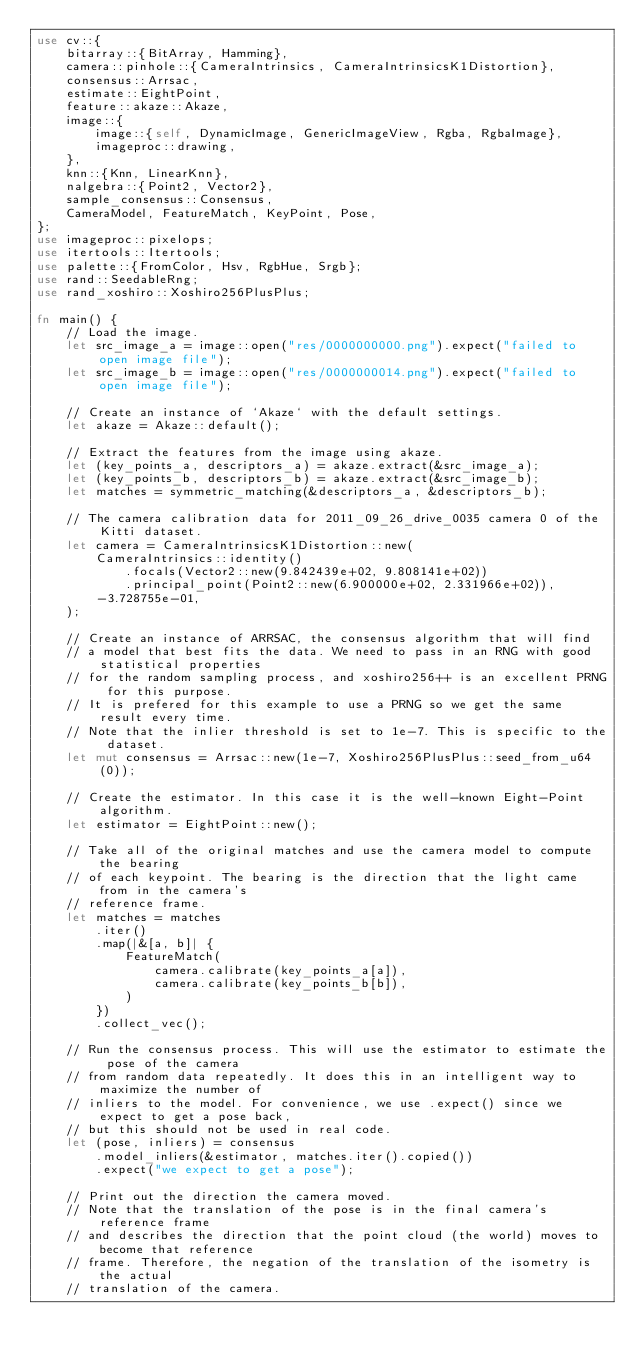<code> <loc_0><loc_0><loc_500><loc_500><_Rust_>use cv::{
    bitarray::{BitArray, Hamming},
    camera::pinhole::{CameraIntrinsics, CameraIntrinsicsK1Distortion},
    consensus::Arrsac,
    estimate::EightPoint,
    feature::akaze::Akaze,
    image::{
        image::{self, DynamicImage, GenericImageView, Rgba, RgbaImage},
        imageproc::drawing,
    },
    knn::{Knn, LinearKnn},
    nalgebra::{Point2, Vector2},
    sample_consensus::Consensus,
    CameraModel, FeatureMatch, KeyPoint, Pose,
};
use imageproc::pixelops;
use itertools::Itertools;
use palette::{FromColor, Hsv, RgbHue, Srgb};
use rand::SeedableRng;
use rand_xoshiro::Xoshiro256PlusPlus;

fn main() {
    // Load the image.
    let src_image_a = image::open("res/0000000000.png").expect("failed to open image file");
    let src_image_b = image::open("res/0000000014.png").expect("failed to open image file");

    // Create an instance of `Akaze` with the default settings.
    let akaze = Akaze::default();

    // Extract the features from the image using akaze.
    let (key_points_a, descriptors_a) = akaze.extract(&src_image_a);
    let (key_points_b, descriptors_b) = akaze.extract(&src_image_b);
    let matches = symmetric_matching(&descriptors_a, &descriptors_b);

    // The camera calibration data for 2011_09_26_drive_0035 camera 0 of the Kitti dataset.
    let camera = CameraIntrinsicsK1Distortion::new(
        CameraIntrinsics::identity()
            .focals(Vector2::new(9.842439e+02, 9.808141e+02))
            .principal_point(Point2::new(6.900000e+02, 2.331966e+02)),
        -3.728755e-01,
    );

    // Create an instance of ARRSAC, the consensus algorithm that will find
    // a model that best fits the data. We need to pass in an RNG with good statistical properties
    // for the random sampling process, and xoshiro256++ is an excellent PRNG for this purpose.
    // It is prefered for this example to use a PRNG so we get the same result every time.
    // Note that the inlier threshold is set to 1e-7. This is specific to the dataset.
    let mut consensus = Arrsac::new(1e-7, Xoshiro256PlusPlus::seed_from_u64(0));

    // Create the estimator. In this case it is the well-known Eight-Point algorithm.
    let estimator = EightPoint::new();

    // Take all of the original matches and use the camera model to compute the bearing
    // of each keypoint. The bearing is the direction that the light came from in the camera's
    // reference frame.
    let matches = matches
        .iter()
        .map(|&[a, b]| {
            FeatureMatch(
                camera.calibrate(key_points_a[a]),
                camera.calibrate(key_points_b[b]),
            )
        })
        .collect_vec();

    // Run the consensus process. This will use the estimator to estimate the pose of the camera
    // from random data repeatedly. It does this in an intelligent way to maximize the number of
    // inliers to the model. For convenience, we use .expect() since we expect to get a pose back,
    // but this should not be used in real code.
    let (pose, inliers) = consensus
        .model_inliers(&estimator, matches.iter().copied())
        .expect("we expect to get a pose");

    // Print out the direction the camera moved.
    // Note that the translation of the pose is in the final camera's reference frame
    // and describes the direction that the point cloud (the world) moves to become that reference
    // frame. Therefore, the negation of the translation of the isometry is the actual
    // translation of the camera.</code> 